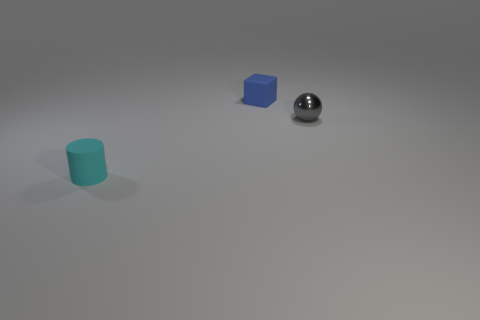Are there any large things of the same shape as the small blue object?
Offer a very short reply. No. There is a blue rubber thing that is the same size as the gray metal object; what is its shape?
Offer a very short reply. Cube. Is the number of cylinders in front of the tiny cyan cylinder the same as the number of small cylinders that are behind the small blue rubber cube?
Offer a terse response. Yes. What size is the rubber object behind the thing to the left of the cube?
Your response must be concise. Small. Is there a gray ball of the same size as the blue cube?
Offer a terse response. Yes. There is a cylinder that is made of the same material as the small cube; what is its color?
Your answer should be very brief. Cyan. Are there fewer big cyan matte spheres than gray metallic balls?
Give a very brief answer. Yes. What is the material of the object that is both on the right side of the small rubber cylinder and left of the small metal thing?
Keep it short and to the point. Rubber. There is a small matte object to the right of the cylinder; is there a small cyan thing that is in front of it?
Provide a short and direct response. Yes. How many tiny cubes are the same color as the tiny cylinder?
Make the answer very short. 0. 